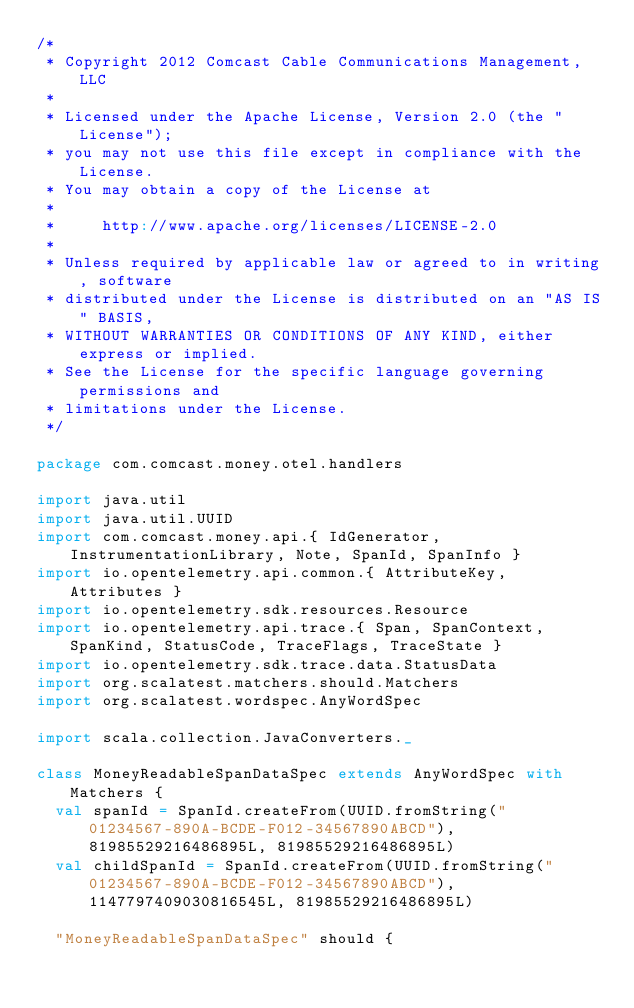<code> <loc_0><loc_0><loc_500><loc_500><_Scala_>/*
 * Copyright 2012 Comcast Cable Communications Management, LLC
 *
 * Licensed under the Apache License, Version 2.0 (the "License");
 * you may not use this file except in compliance with the License.
 * You may obtain a copy of the License at
 *
 *     http://www.apache.org/licenses/LICENSE-2.0
 *
 * Unless required by applicable law or agreed to in writing, software
 * distributed under the License is distributed on an "AS IS" BASIS,
 * WITHOUT WARRANTIES OR CONDITIONS OF ANY KIND, either express or implied.
 * See the License for the specific language governing permissions and
 * limitations under the License.
 */

package com.comcast.money.otel.handlers

import java.util
import java.util.UUID
import com.comcast.money.api.{ IdGenerator, InstrumentationLibrary, Note, SpanId, SpanInfo }
import io.opentelemetry.api.common.{ AttributeKey, Attributes }
import io.opentelemetry.sdk.resources.Resource
import io.opentelemetry.api.trace.{ Span, SpanContext, SpanKind, StatusCode, TraceFlags, TraceState }
import io.opentelemetry.sdk.trace.data.StatusData
import org.scalatest.matchers.should.Matchers
import org.scalatest.wordspec.AnyWordSpec

import scala.collection.JavaConverters._

class MoneyReadableSpanDataSpec extends AnyWordSpec with Matchers {
  val spanId = SpanId.createFrom(UUID.fromString("01234567-890A-BCDE-F012-34567890ABCD"), 81985529216486895L, 81985529216486895L)
  val childSpanId = SpanId.createFrom(UUID.fromString("01234567-890A-BCDE-F012-34567890ABCD"), 1147797409030816545L, 81985529216486895L)

  "MoneyReadableSpanDataSpec" should {</code> 